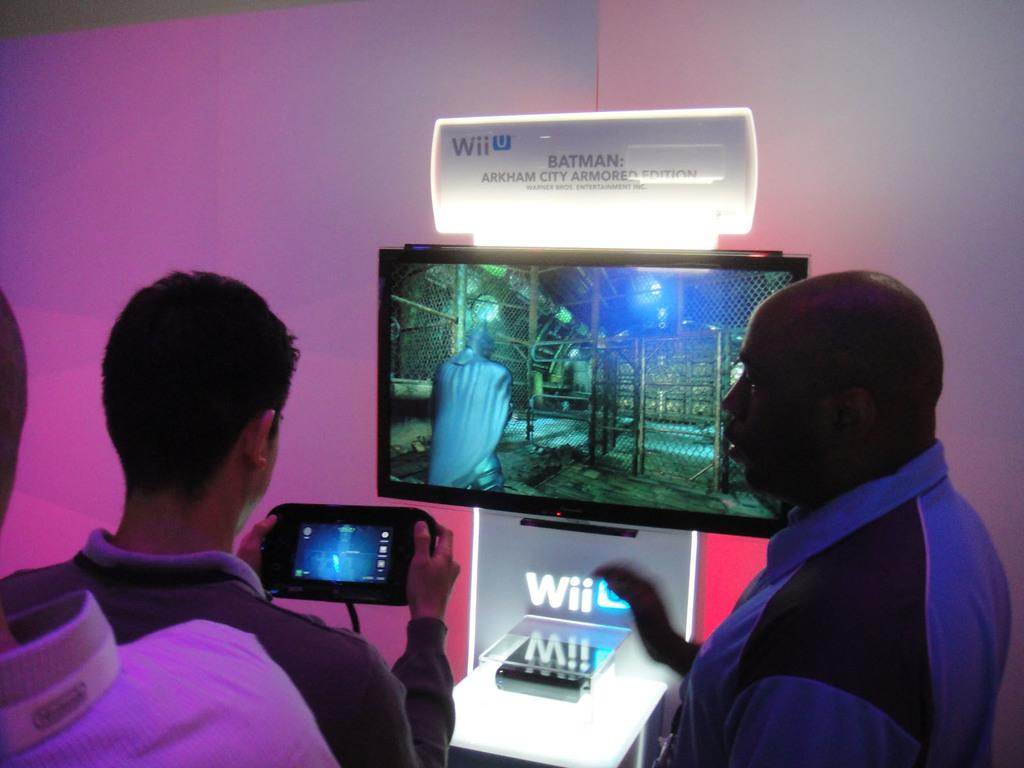<image>
Create a compact narrative representing the image presented. Some people play a Batman game on Wii U. 